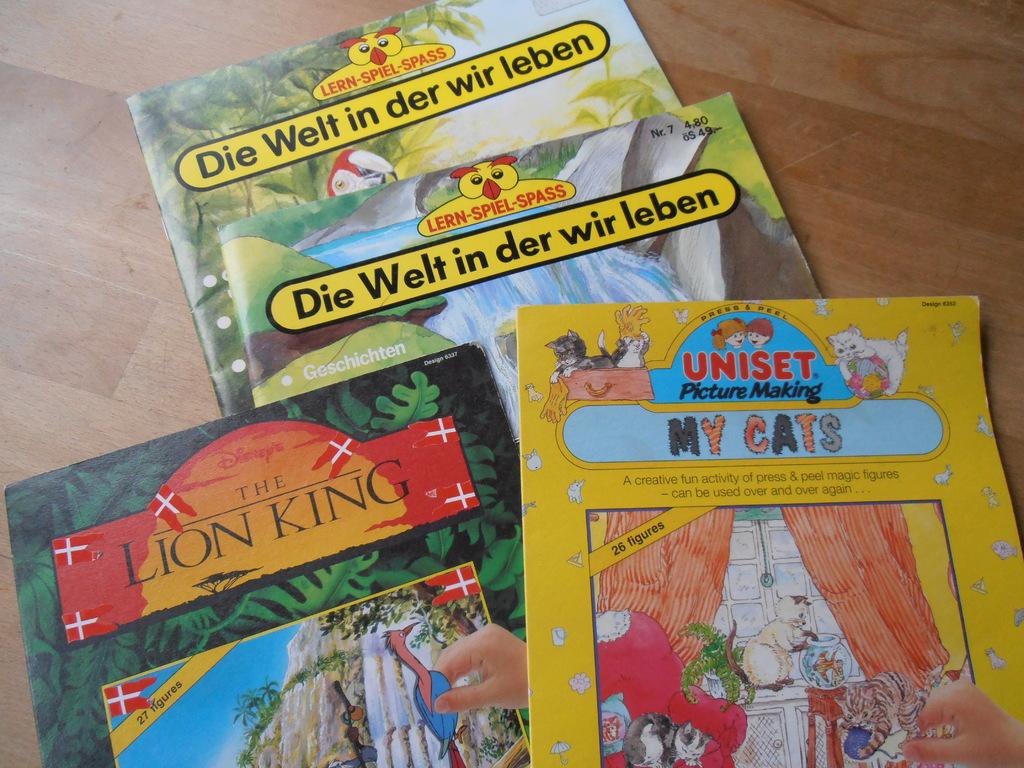What is the name of the activity book?
Offer a terse response. My cats. 